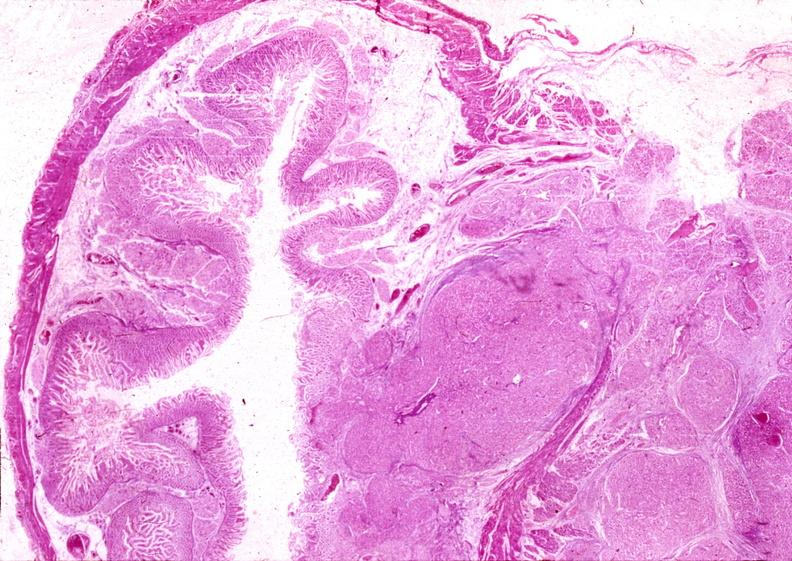what does this image show?
Answer the question using a single word or phrase. Islet cell carcinoma 